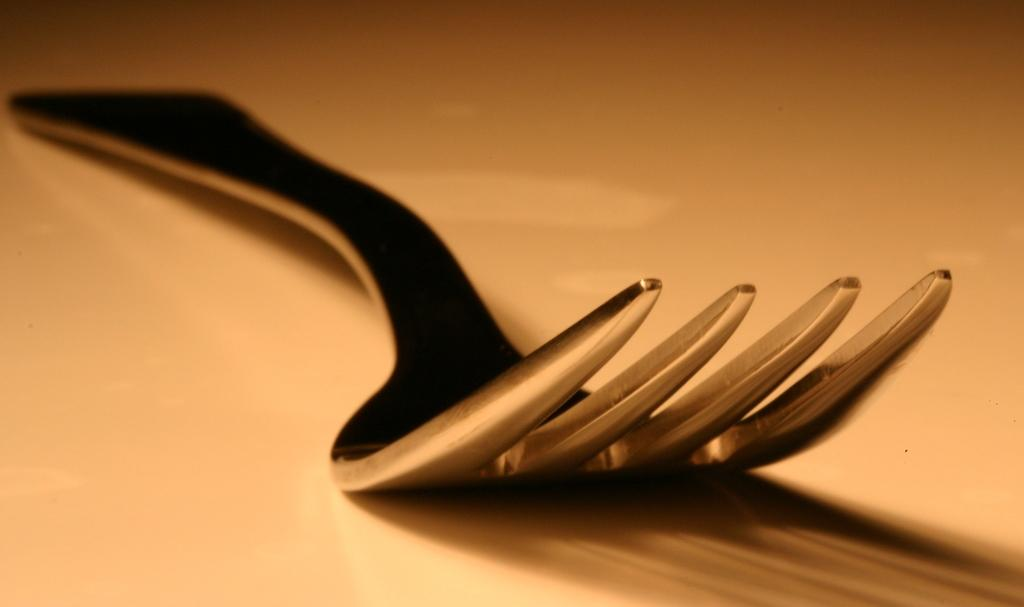What utensil can be seen in the image? There is a fork in the image. What is the color of the surface the fork is resting on? The surface the fork is on has an orange color. Where is the library located in the image? There is no library present in the image. What type of paint is used on the roof in the image? There is no roof or paint mentioned in the image; it only features a fork on an orange surface. 